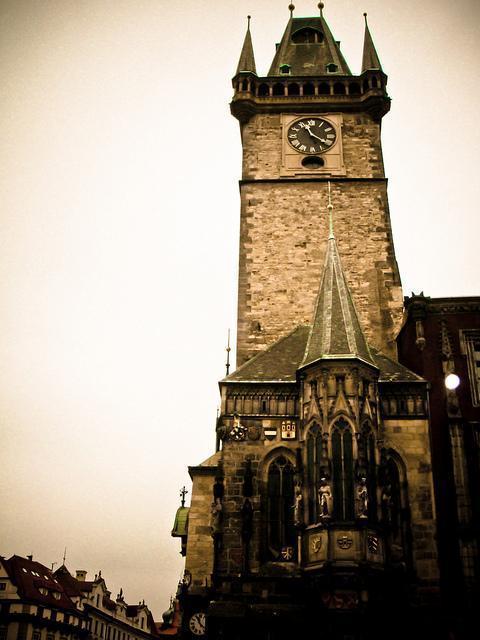How many spires does the building have?
Give a very brief answer. 3. 